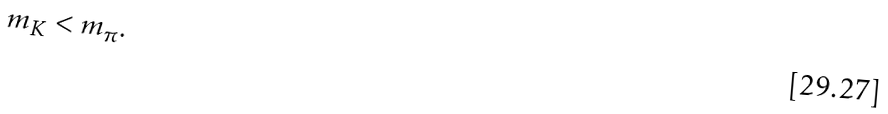<formula> <loc_0><loc_0><loc_500><loc_500>m _ { K } < m _ { \pi } .</formula> 